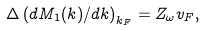<formula> <loc_0><loc_0><loc_500><loc_500>\Delta \left ( d M _ { 1 } ( { k } ) / d k \right ) _ { k _ { F } } = Z _ { \omega } v _ { F } ,</formula> 